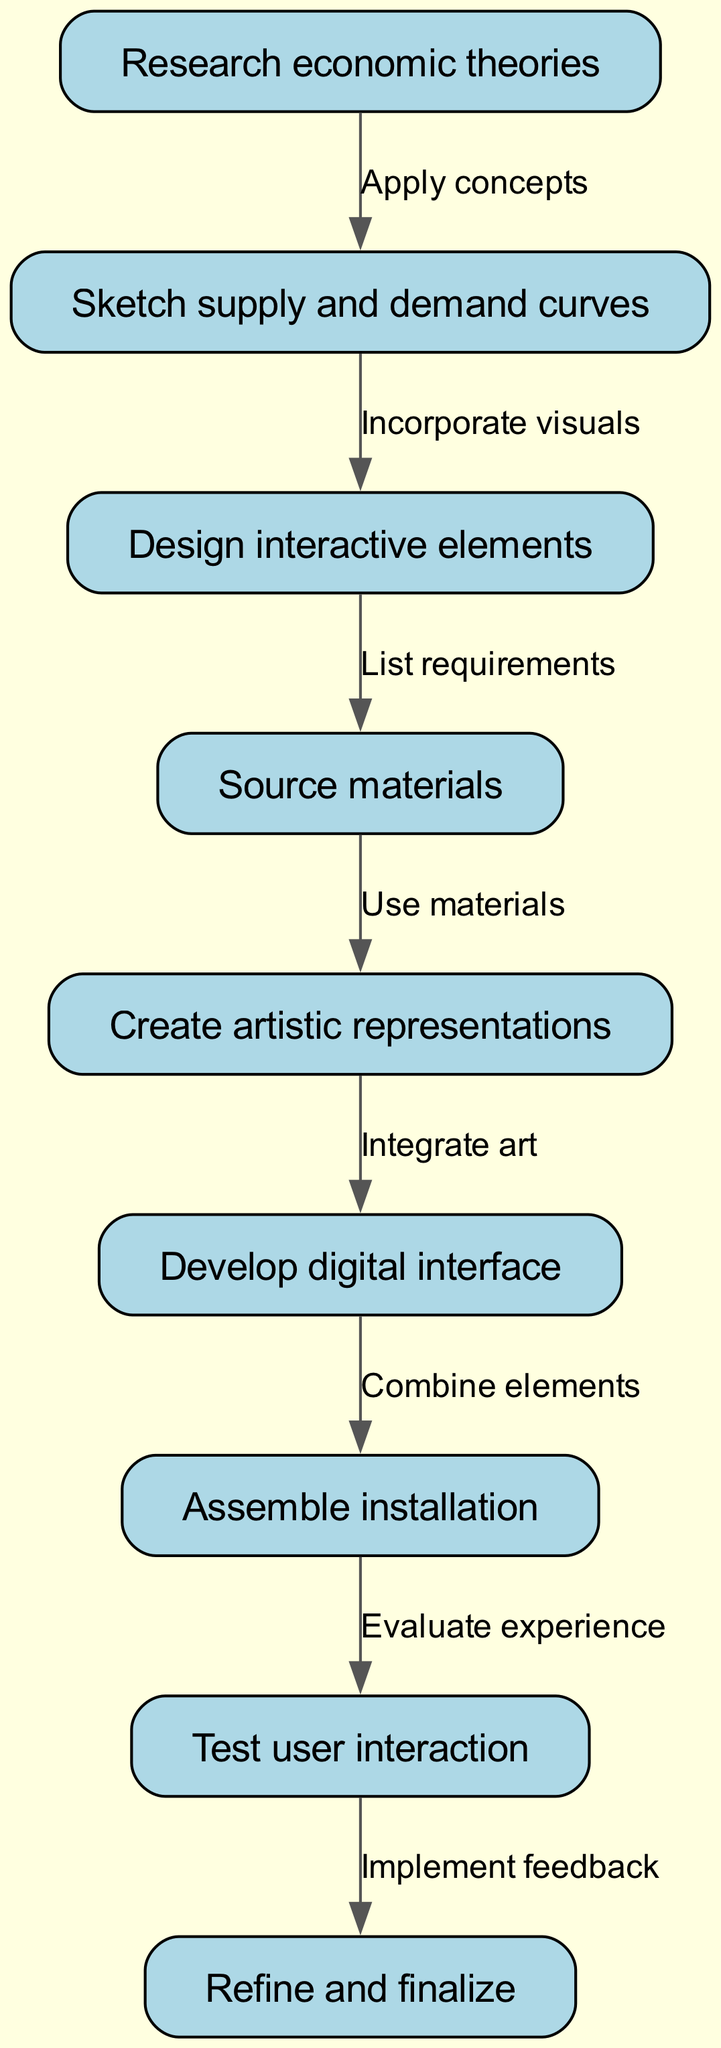What is the first step in the workflow? The first step in the workflow is "Research economic theories" as indicated by the starting node.
Answer: Research economic theories How many nodes are there in the diagram? By counting all the distinct tasks or actions in the diagram, we find there are a total of nine nodes listed.
Answer: Nine What is the final step of the installation process? The final step is "Refine and finalize," which is the last node in the flowchart that completes the installation process.
Answer: Refine and finalize What step comes after designing interactive elements? The step that comes after "Design interactive elements" is "Source materials," as it follows sequentially in the flow of the diagram.
Answer: Source materials Which two steps show an interactive connection between user interaction and feedback? The steps showing this connection are "Test user interaction" and "Refine and finalize," where the feedback from testing informs the finalization process.
Answer: Test user interaction and Refine and finalize In which step do artistic representations get created? "Create artistic representations" is the specific step where the artistic output is realized based on previous research and curve sketches.
Answer: Create artistic representations What action is taken before developing the digital interface? Before developing the digital interface, the action taken is "Create artistic representations," meaning artists integrate their artwork into the interactive digital platform.
Answer: Create artistic representations What does the edge connecting "Assemble installation" to "Test user interaction" indicate? This edge indicates a transition where after the physical assembly of the installation, the next logical step is to evaluate how users interact with it.
Answer: Evaluate experience Which task directly follows sourcing materials? The task that directly follows "Source materials" is "Create artistic representations," which means using the sourced materials to develop the installation’s artistic components.
Answer: Create artistic representations 